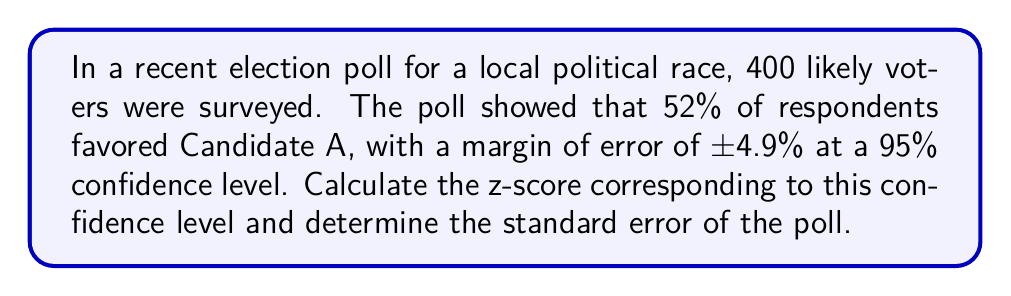Provide a solution to this math problem. Let's approach this step-by-step:

1) First, we need to recall that for a 95% confidence level, the z-score is 1.96. This is a standard value used in statistics.

2) The margin of error (MOE) is given by the formula:

   $$MOE = z \times \sqrt{\frac{p(1-p)}{n}}$$

   Where:
   - z is the z-score
   - p is the sample proportion
   - n is the sample size

3) We're given that the MOE is 0.049 (4.9%), p is 0.52 (52%), and n is 400.

4) We can rearrange the MOE formula to solve for the standard error:

   $$SE = \sqrt{\frac{p(1-p)}{n}} = \frac{MOE}{z}$$

5) Plugging in our known values:

   $$SE = \frac{0.049}{1.96} = 0.025$$

6) We can verify this by calculating the standard error directly:

   $$SE = \sqrt{\frac{0.52(1-0.52)}{400}} = \sqrt{\frac{0.2496}{400}} = 0.025$$

This confirms our calculation.
Answer: z-score: 1.96, Standard Error: 0.025 